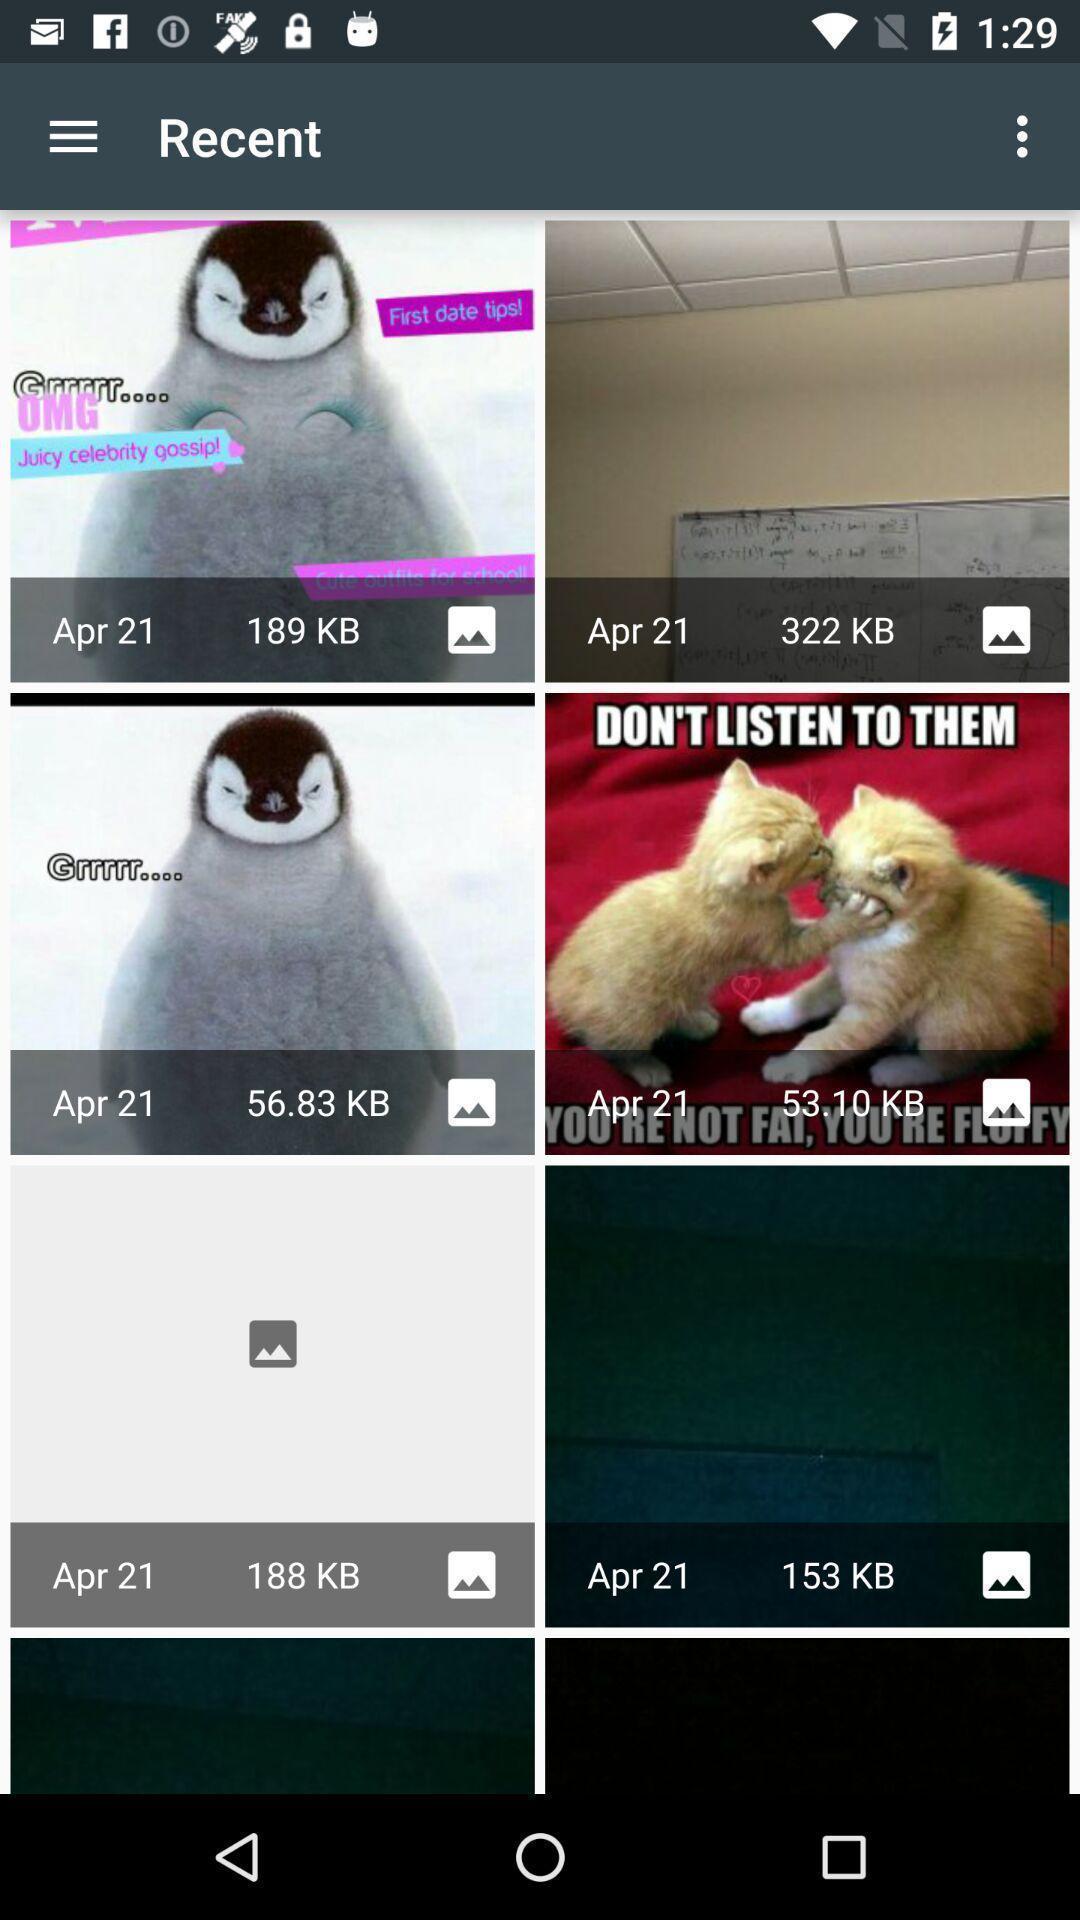Summarize the information in this screenshot. Various recent images displayed in gallery app. 